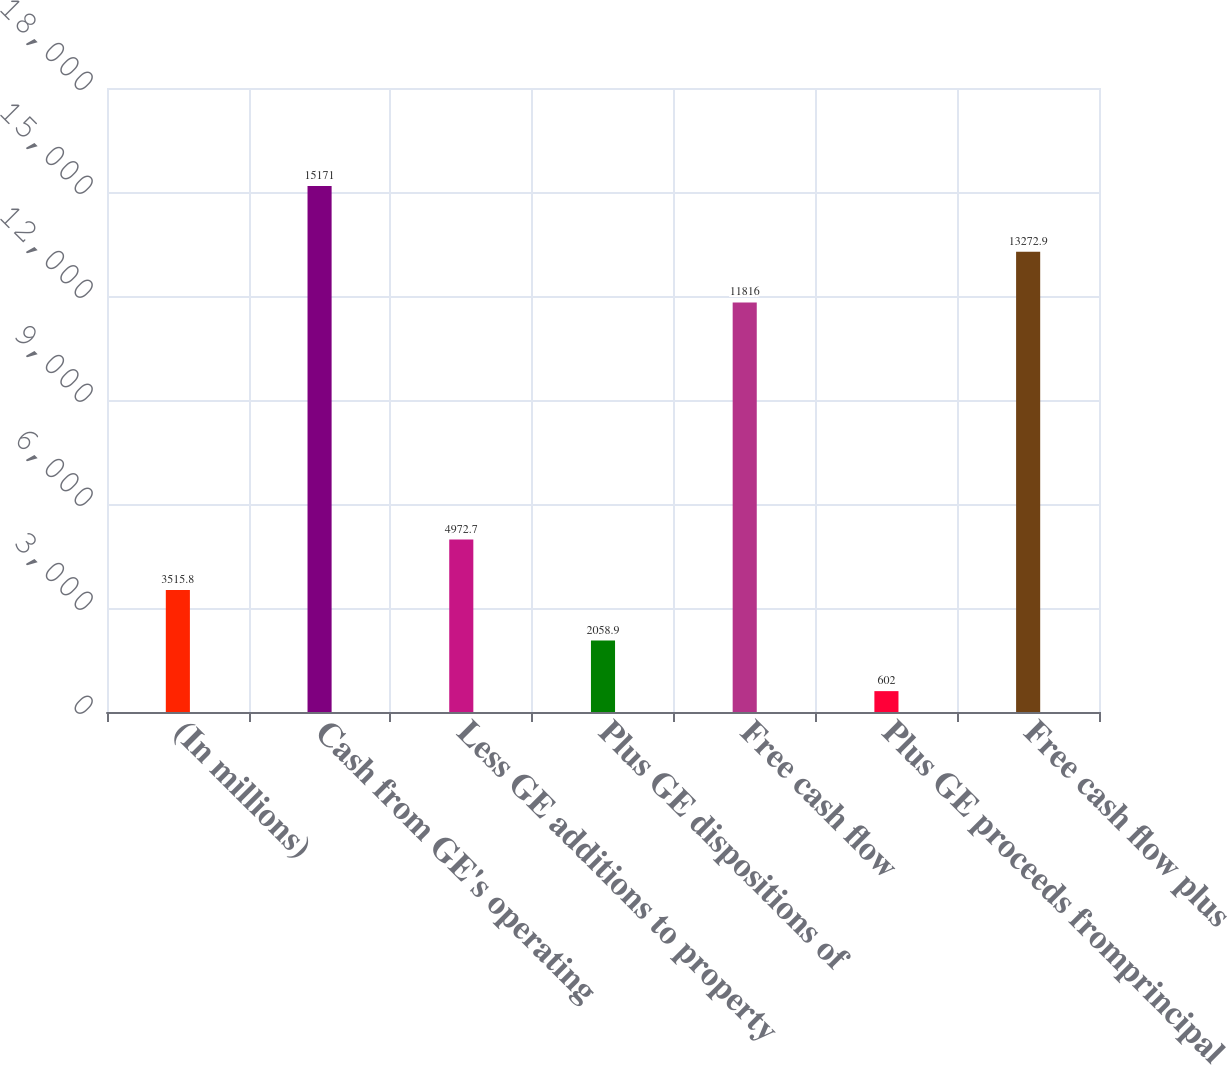Convert chart. <chart><loc_0><loc_0><loc_500><loc_500><bar_chart><fcel>(In millions)<fcel>Cash from GE's operating<fcel>Less GE additions to property<fcel>Plus GE dispositions of<fcel>Free cash flow<fcel>Plus GE proceeds fromprincipal<fcel>Free cash flow plus<nl><fcel>3515.8<fcel>15171<fcel>4972.7<fcel>2058.9<fcel>11816<fcel>602<fcel>13272.9<nl></chart> 